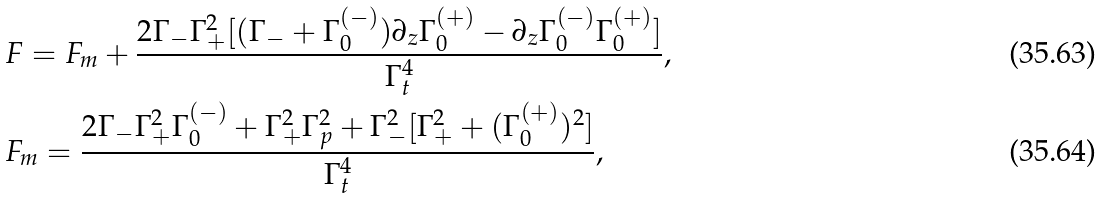Convert formula to latex. <formula><loc_0><loc_0><loc_500><loc_500>& F = F _ { m } + \frac { 2 \Gamma _ { - } \Gamma _ { + } ^ { 2 } [ ( \Gamma _ { - } + \Gamma ^ { ( - ) } _ { 0 } ) \partial _ { z } \Gamma ^ { ( + ) } _ { 0 } - \partial _ { z } \Gamma ^ { ( - ) } _ { 0 } \Gamma ^ { ( + ) } _ { 0 } ] } { \Gamma _ { t } ^ { 4 } } , \\ & F _ { m } = \frac { 2 \Gamma _ { - } \Gamma _ { + } ^ { 2 } \Gamma ^ { ( - ) } _ { 0 } + \Gamma _ { + } ^ { 2 } \Gamma _ { p } ^ { 2 } + \Gamma _ { - } ^ { 2 } [ \Gamma _ { + } ^ { 2 } + ( \Gamma ^ { ( + ) } _ { 0 } ) ^ { 2 } ] } { \Gamma _ { t } ^ { 4 } } ,</formula> 